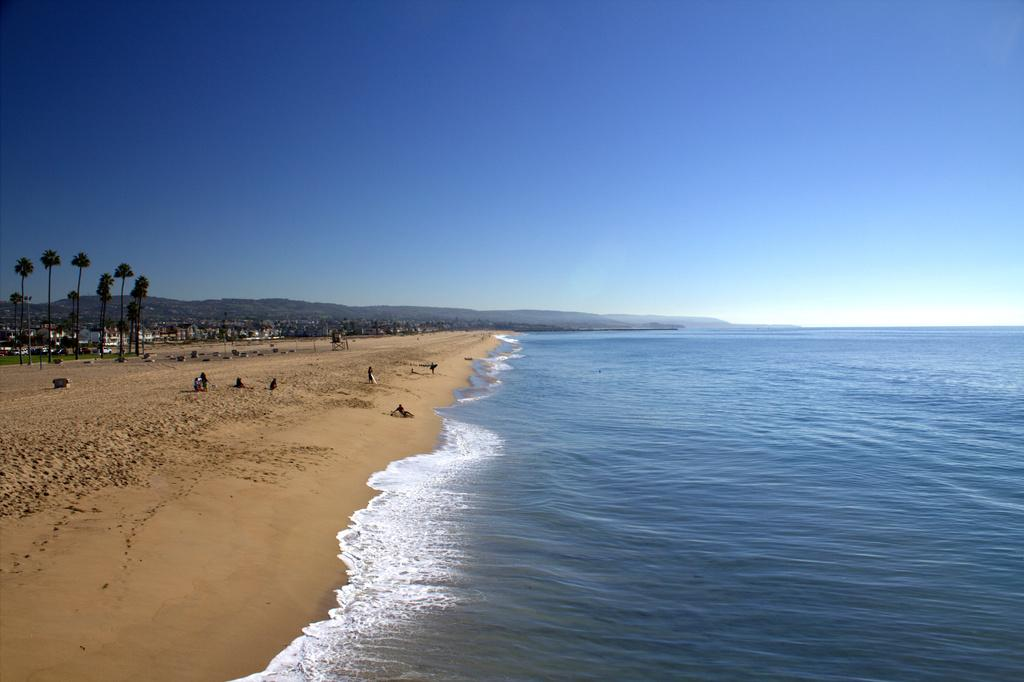What natural element is present in the image? There is water and sand in the image. Can you describe the people in the image? There are persons in the image. What type of vegetation is visible in the image? There are trees in the image. What man-made structures can be seen in the image? There are buildings in the image. What geographical feature is visible in the background of the image? There is a mountain visible in the background of the image. What else can be seen in the background of the image? The sky is visible in the background of the image. How many horses are wearing a locket in the image? There are no horses or lockets present in the image. What type of things are being carried by the persons in the image? The provided facts do not mention any specific things being carried by the persons in the image. 